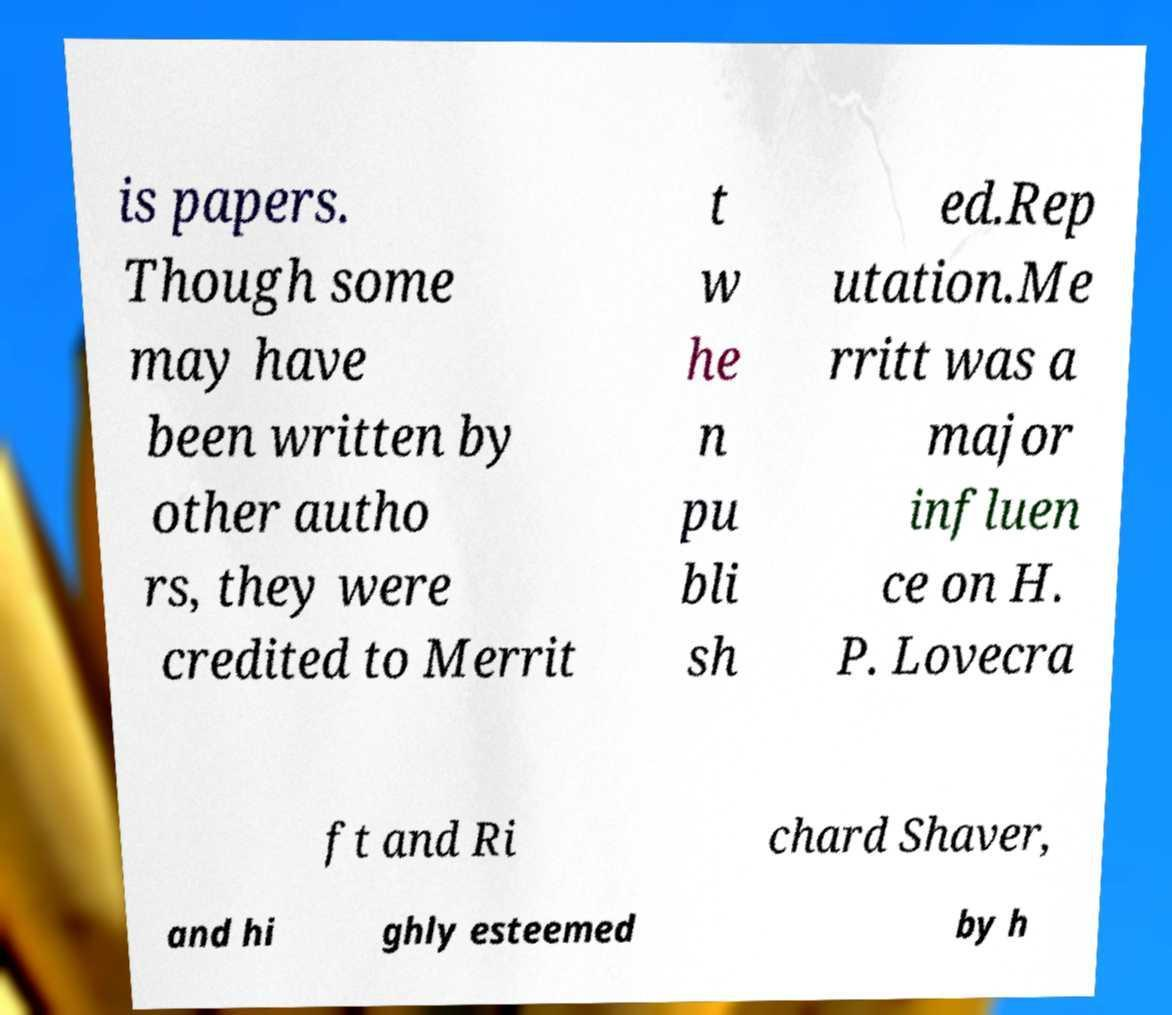Please read and relay the text visible in this image. What does it say? is papers. Though some may have been written by other autho rs, they were credited to Merrit t w he n pu bli sh ed.Rep utation.Me rritt was a major influen ce on H. P. Lovecra ft and Ri chard Shaver, and hi ghly esteemed by h 